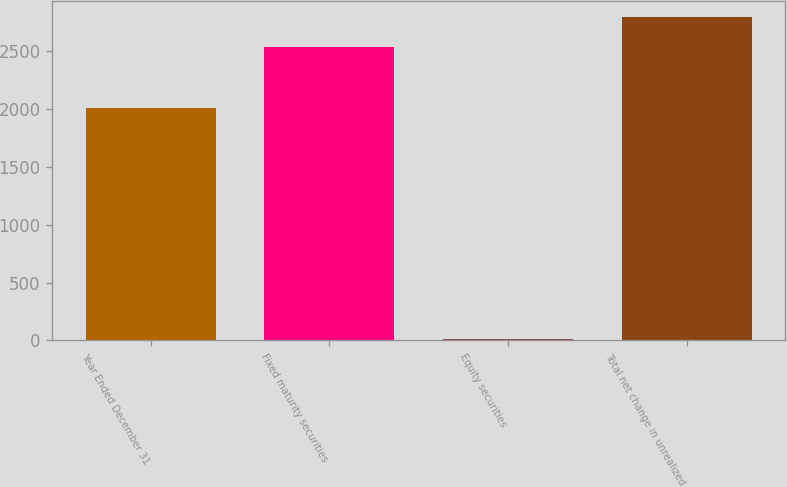Convert chart. <chart><loc_0><loc_0><loc_500><loc_500><bar_chart><fcel>Year Ended December 31<fcel>Fixed maturity securities<fcel>Equity securities<fcel>Total net change in unrealized<nl><fcel>2013<fcel>2541<fcel>15<fcel>2795.1<nl></chart> 